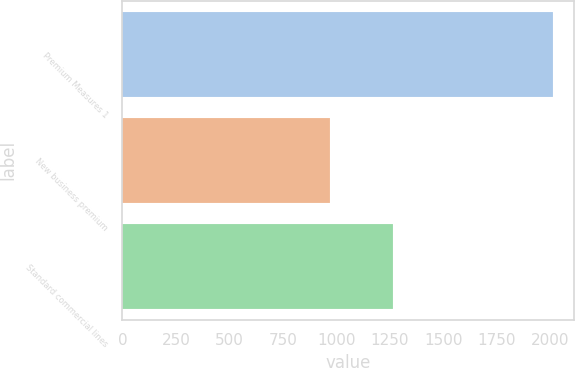Convert chart to OTSL. <chart><loc_0><loc_0><loc_500><loc_500><bar_chart><fcel>Premium Measures 1<fcel>New business premium<fcel>Standard commercial lines<nl><fcel>2012<fcel>968<fcel>1263<nl></chart> 